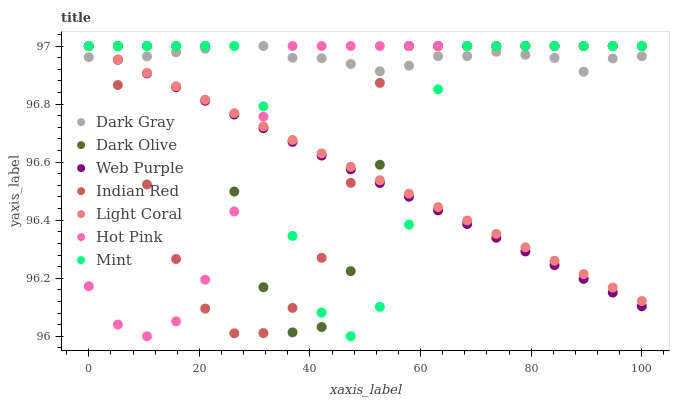Does Web Purple have the minimum area under the curve?
Answer yes or no. Yes. Does Dark Gray have the maximum area under the curve?
Answer yes or no. Yes. Does Hot Pink have the minimum area under the curve?
Answer yes or no. No. Does Hot Pink have the maximum area under the curve?
Answer yes or no. No. Is Web Purple the smoothest?
Answer yes or no. Yes. Is Mint the roughest?
Answer yes or no. Yes. Is Hot Pink the smoothest?
Answer yes or no. No. Is Hot Pink the roughest?
Answer yes or no. No. Does Hot Pink have the lowest value?
Answer yes or no. Yes. Does Dark Olive have the lowest value?
Answer yes or no. No. Does Mint have the highest value?
Answer yes or no. Yes. Does Dark Gray intersect Hot Pink?
Answer yes or no. Yes. Is Dark Gray less than Hot Pink?
Answer yes or no. No. Is Dark Gray greater than Hot Pink?
Answer yes or no. No. 